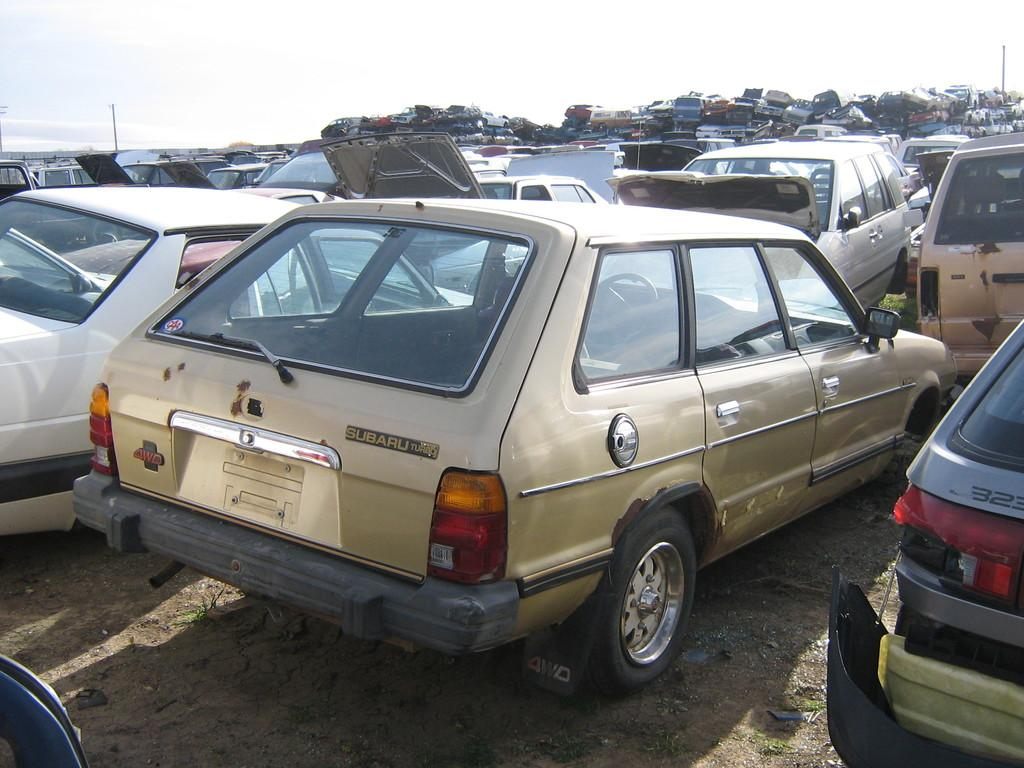What type of location is depicted in the image? The image depicts a cars junkyard. What can be seen in the background of the image? There is a sky visible at the top of the image. How many beggars are present in the image? There are no beggars present in the image; it depicts a cars junkyard. What type of game is being played in the image? There is no game being played in the image; it depicts a cars junkyard. 